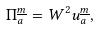<formula> <loc_0><loc_0><loc_500><loc_500>\Pi ^ { \underline { m } } _ { a } = W ^ { 2 } u _ { a } ^ { \underline { m } } ,</formula> 